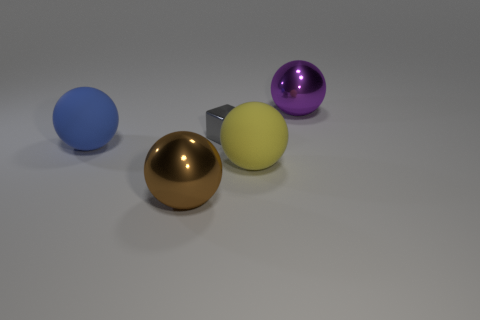Is there any other thing that is the same shape as the tiny gray thing?
Offer a very short reply. No. The other sphere that is the same material as the large purple ball is what color?
Offer a very short reply. Brown. What number of objects are either big brown metal spheres or big red cubes?
Ensure brevity in your answer.  1. Do the brown sphere and the metallic ball on the right side of the yellow rubber ball have the same size?
Keep it short and to the point. Yes. There is a big matte sphere on the right side of the large metallic object in front of the big matte ball to the left of the small gray metal object; what is its color?
Make the answer very short. Yellow. The cube is what color?
Provide a short and direct response. Gray. Is the number of big metal spheres on the right side of the large yellow matte ball greater than the number of shiny blocks that are right of the gray thing?
Your response must be concise. Yes. Does the large yellow rubber object have the same shape as the thing that is behind the gray object?
Your answer should be compact. Yes. There is a metal object in front of the big blue matte object; is it the same size as the gray thing right of the brown thing?
Ensure brevity in your answer.  No. Is there a large yellow ball that is left of the large blue sphere behind the large sphere in front of the yellow object?
Provide a short and direct response. No. 